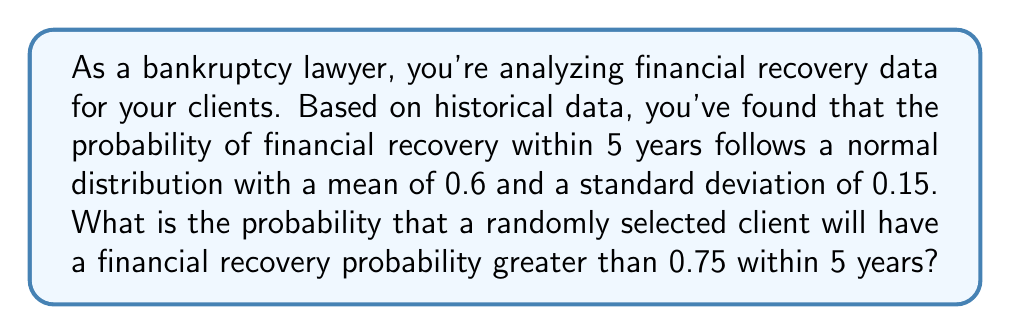Give your solution to this math problem. To solve this problem, we'll use the properties of the normal distribution and the z-score formula.

Step 1: Identify the given information
- The probability of financial recovery follows a normal distribution
- Mean (μ) = 0.6
- Standard deviation (σ) = 0.15
- We want to find P(X > 0.75), where X is the probability of financial recovery

Step 2: Calculate the z-score for the given value
The z-score formula is: $z = \frac{x - μ}{σ}$

Plugging in our values:
$z = \frac{0.75 - 0.6}{0.15} = \frac{0.15}{0.15} = 1$

Step 3: Use the standard normal distribution table or calculator
We need to find P(Z > 1), where Z is the standard normal random variable.

Using the properties of the standard normal distribution:
P(Z > 1) = 1 - P(Z < 1)

From a standard normal table or calculator, we find:
P(Z < 1) ≈ 0.8413

Therefore:
P(Z > 1) = 1 - 0.8413 = 0.1587

Step 4: Interpret the result
The probability that a randomly selected client will have a financial recovery probability greater than 0.75 within 5 years is approximately 0.1587 or 15.87%.
Answer: 0.1587 (or 15.87%) 